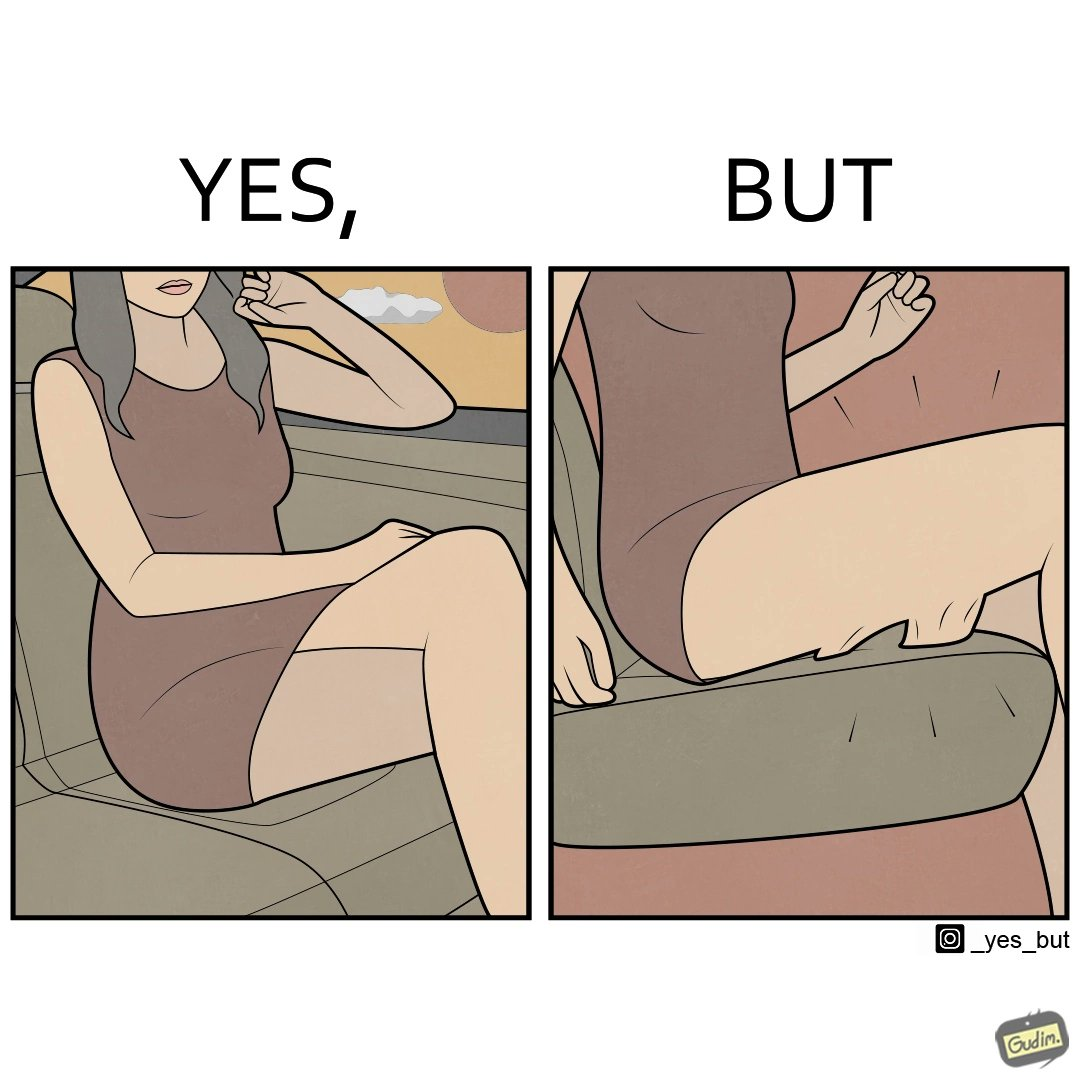What makes this image funny or satirical? The image is ironic, because the woman is wearing a short dress to look stylish but she had to face inconvenience while travelling in car due to her short dress only. 